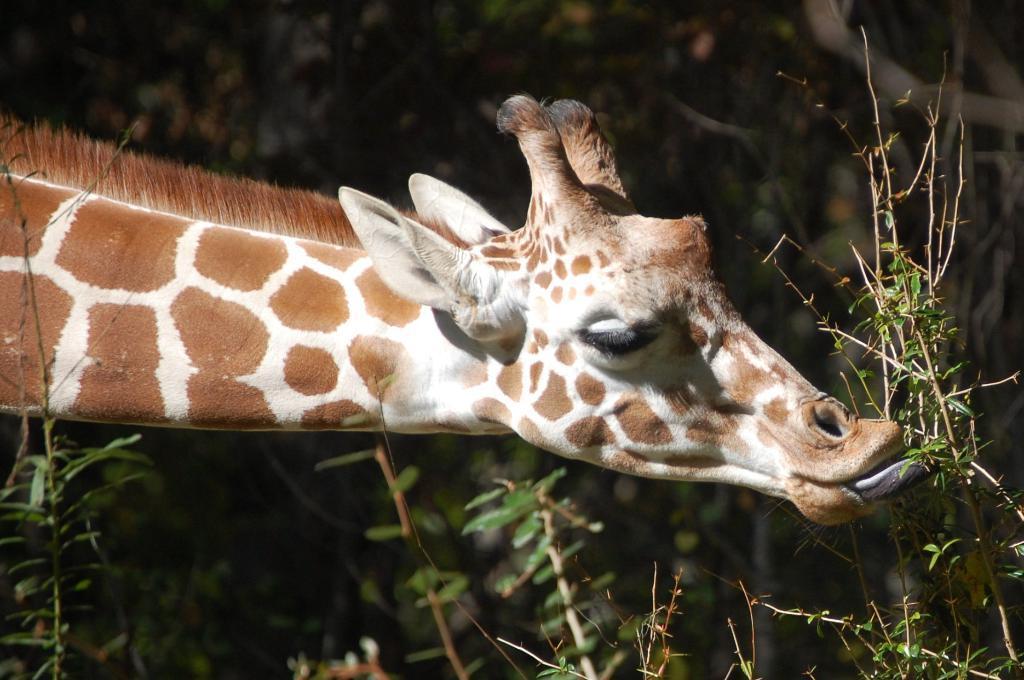Please provide a concise description of this image. In this image I can see a giraffe eating the leaves of a plant. In the background there are many plants and trees. 